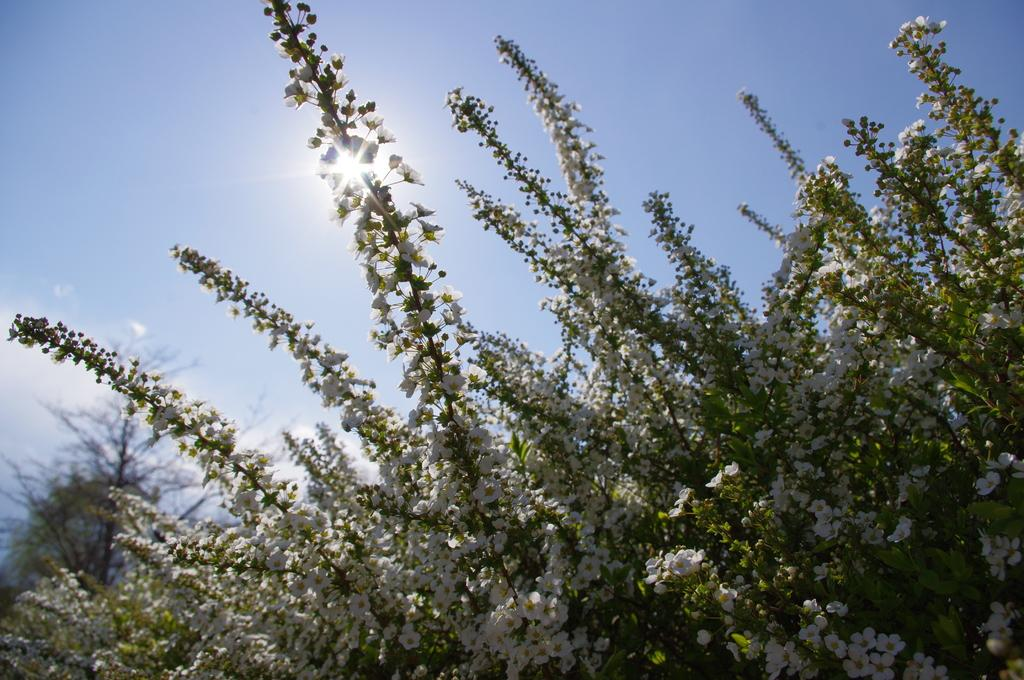What types of living organisms can be seen in the image? Plants and flowers are visible in the image. Where is the tree located in the image? The tree is on the left side of the image. What can be seen in the background of the image? The sky is visible in the background of the image. What type of spark can be seen coming from the flowers in the image? There is no spark present in the image; it features plants and flowers without any visible sparks. 